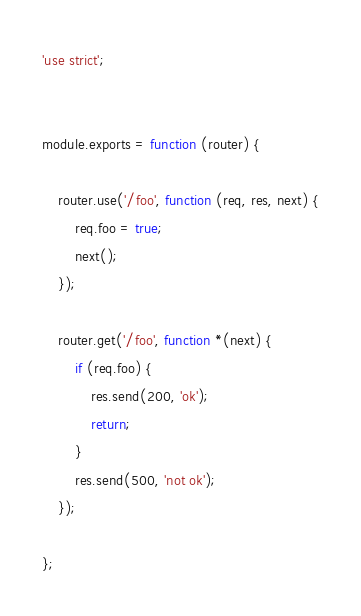Convert code to text. <code><loc_0><loc_0><loc_500><loc_500><_JavaScript_>'use strict';


module.exports = function (router) {

    router.use('/foo', function (req, res, next) {
        req.foo = true;
        next();
    });

    router.get('/foo', function *(next) {
        if (req.foo) {
            res.send(200, 'ok');
            return;
        }
        res.send(500, 'not ok');
    });

};
</code> 